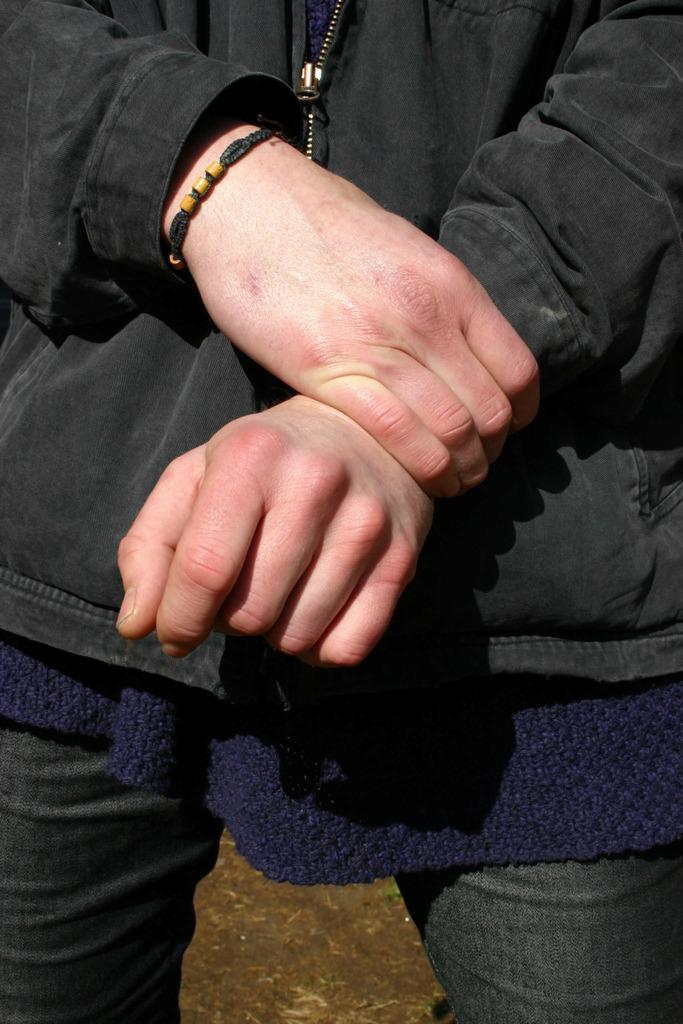What is the main subject of the image? There is a person standing in the image. What is the person wearing? The person is wearing a black coat. Are there any accessories visible on the person? Yes, the person has a hand-band. What color is the butter on the person's hand in the image? There is no butter present in the image; the person has a hand-band. What team does the person belong to in the image? There is no indication of a team in the image; it only shows a person wearing a black coat and a hand-band. 